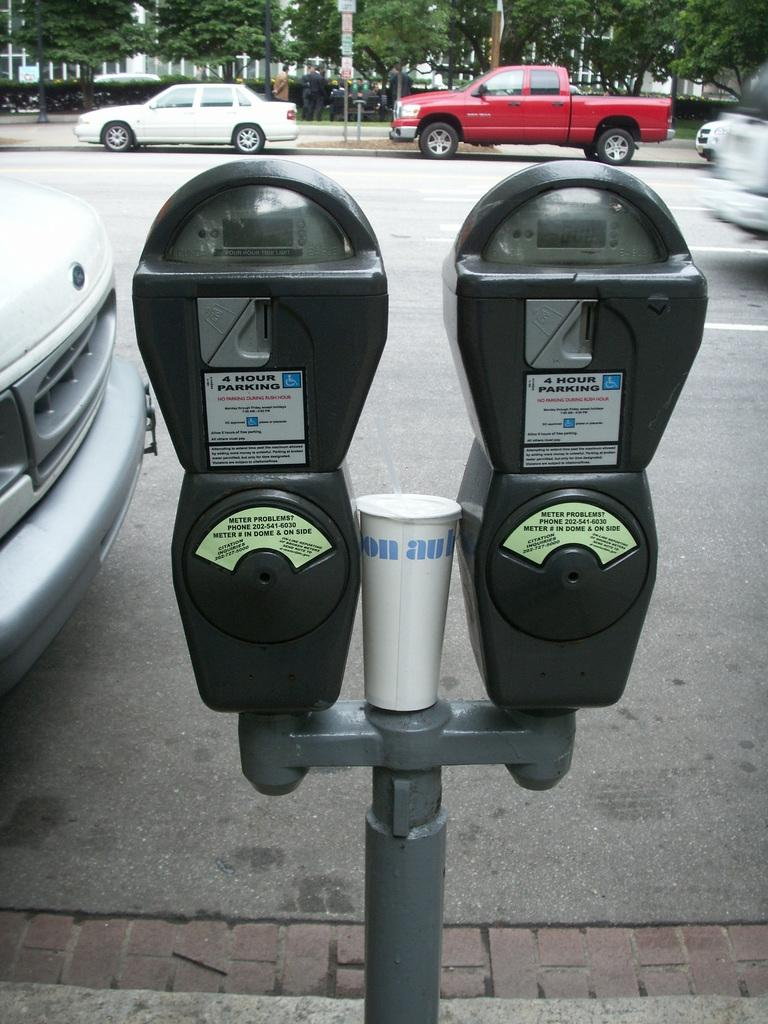<image>
Describe the image concisely. Two parking meters feature 4 hour parking stickers on them. 